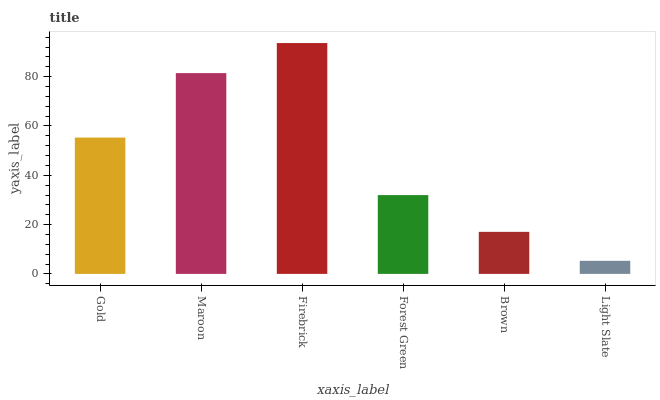Is Maroon the minimum?
Answer yes or no. No. Is Maroon the maximum?
Answer yes or no. No. Is Maroon greater than Gold?
Answer yes or no. Yes. Is Gold less than Maroon?
Answer yes or no. Yes. Is Gold greater than Maroon?
Answer yes or no. No. Is Maroon less than Gold?
Answer yes or no. No. Is Gold the high median?
Answer yes or no. Yes. Is Forest Green the low median?
Answer yes or no. Yes. Is Light Slate the high median?
Answer yes or no. No. Is Maroon the low median?
Answer yes or no. No. 